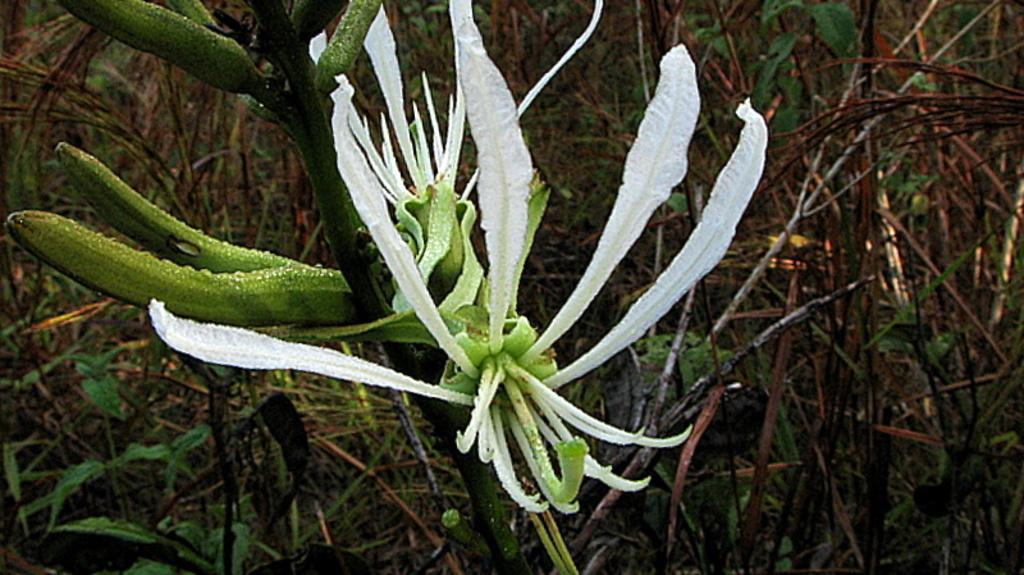What type of living organisms can be seen in the image? Flowers, buds, and plants can be seen in the image. Can you describe the growth stage of the flowers in the image? The flowers in the image are accompanied by buds, which suggests they are in various stages of growth. What is the primary subject of the image? The primary subject of the image is the flowers and plants. What type of teeth can be seen in the image? There are no teeth present in the image; it features flowers, buds, and plants. 